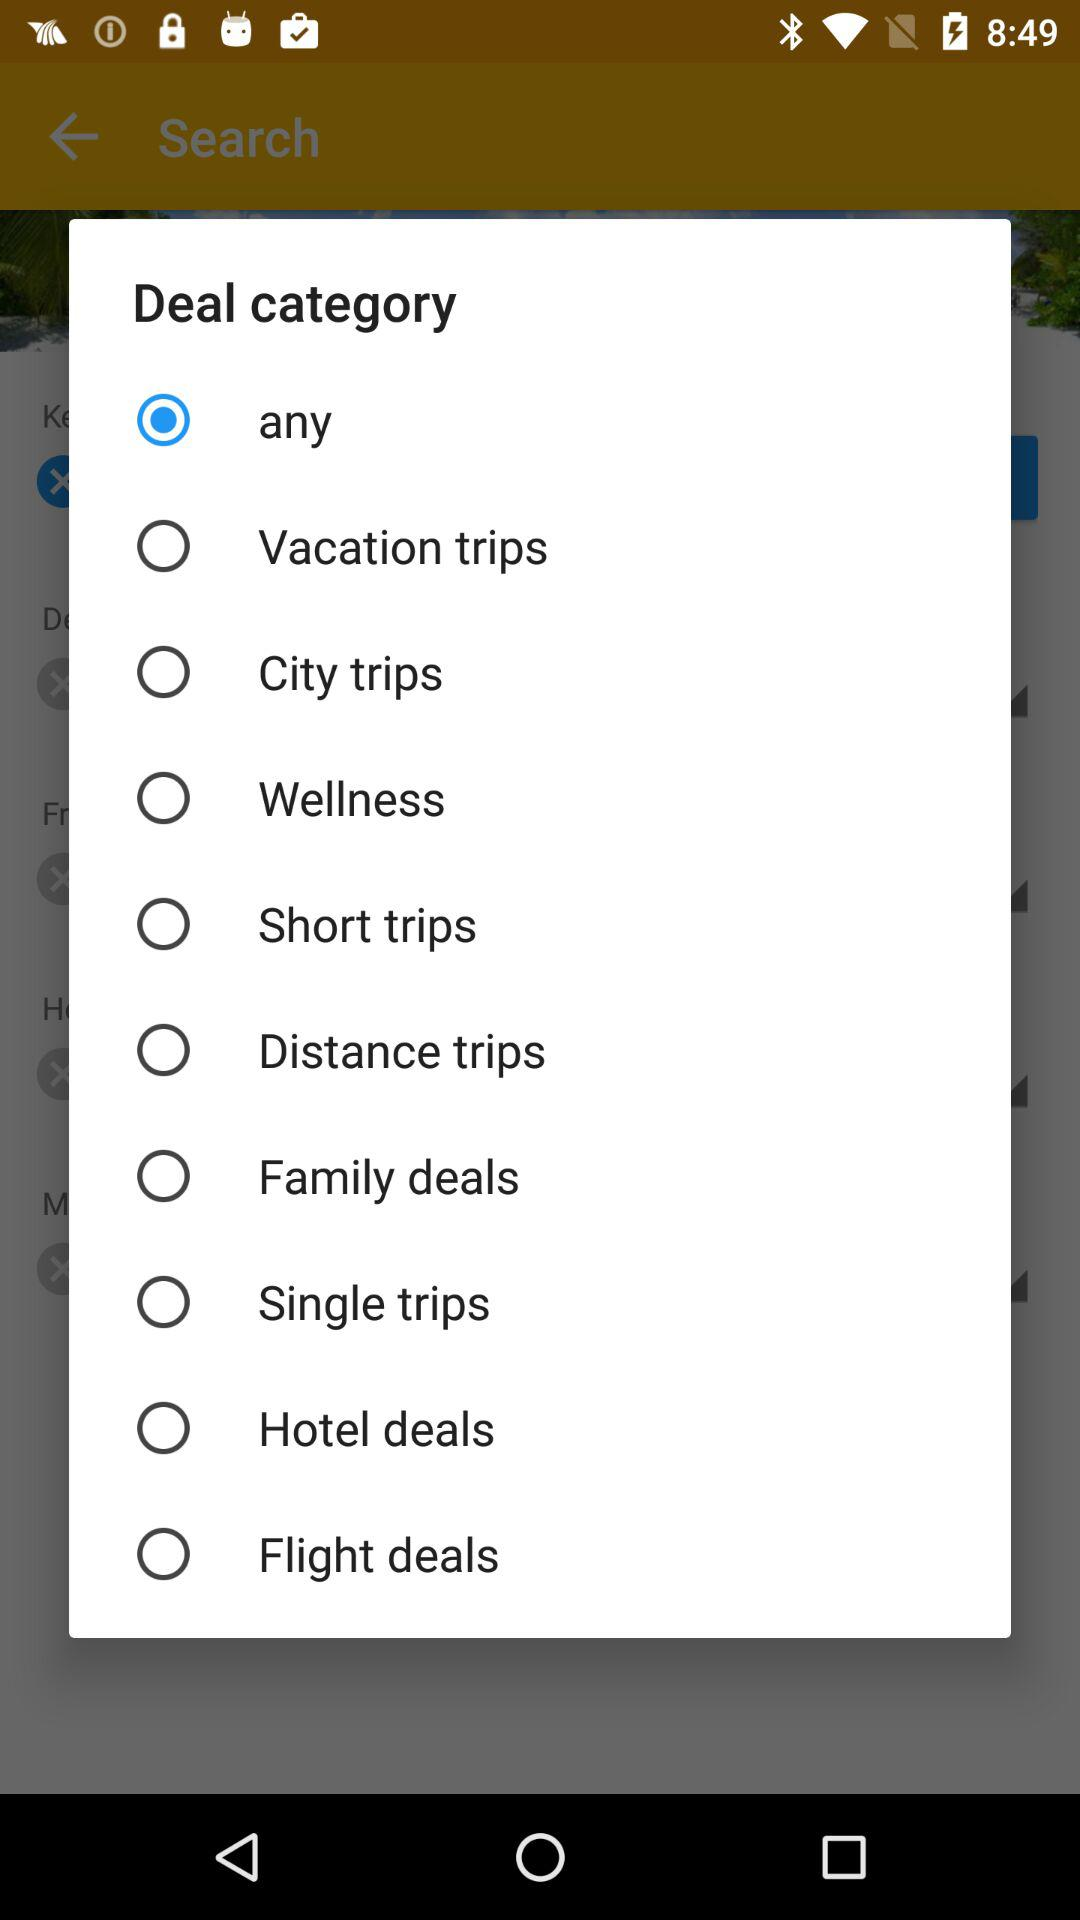Which option is selected? The selected option is "any". 